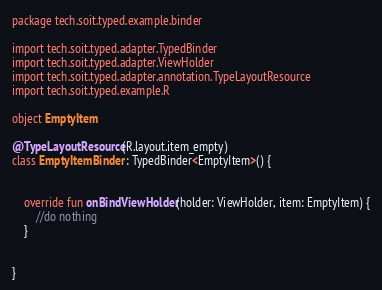Convert code to text. <code><loc_0><loc_0><loc_500><loc_500><_Kotlin_>package tech.soit.typed.example.binder

import tech.soit.typed.adapter.TypedBinder
import tech.soit.typed.adapter.ViewHolder
import tech.soit.typed.adapter.annotation.TypeLayoutResource
import tech.soit.typed.example.R

object EmptyItem

@TypeLayoutResource(R.layout.item_empty)
class EmptyItemBinder : TypedBinder<EmptyItem>() {


    override fun onBindViewHolder(holder: ViewHolder, item: EmptyItem) {
        //do nothing
    }


}</code> 